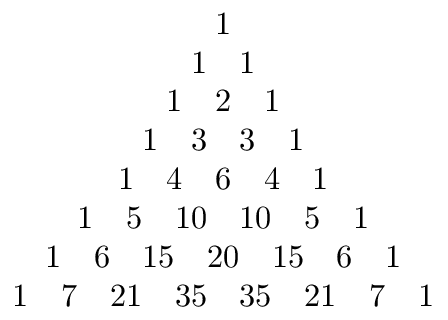Convert formula to latex. <formula><loc_0><loc_0><loc_500><loc_500>\begin{array} { c } { 1 } \\ { 1 \quad 1 } \\ { 1 \quad 2 \quad 1 } \\ { 1 \quad 3 \quad 3 \quad 1 } \\ { 1 \quad 4 \quad 6 \quad 4 \quad 1 } \\ { 1 \quad 5 \quad 1 0 \quad 1 0 \quad 5 \quad 1 } \\ { 1 \quad 6 \quad 1 5 \quad 2 0 \quad 1 5 \quad 6 \quad 1 } \\ { 1 \quad 7 \quad 2 1 \quad 3 5 \quad 3 5 \quad 2 1 \quad 7 \quad 1 } \end{array}</formula> 